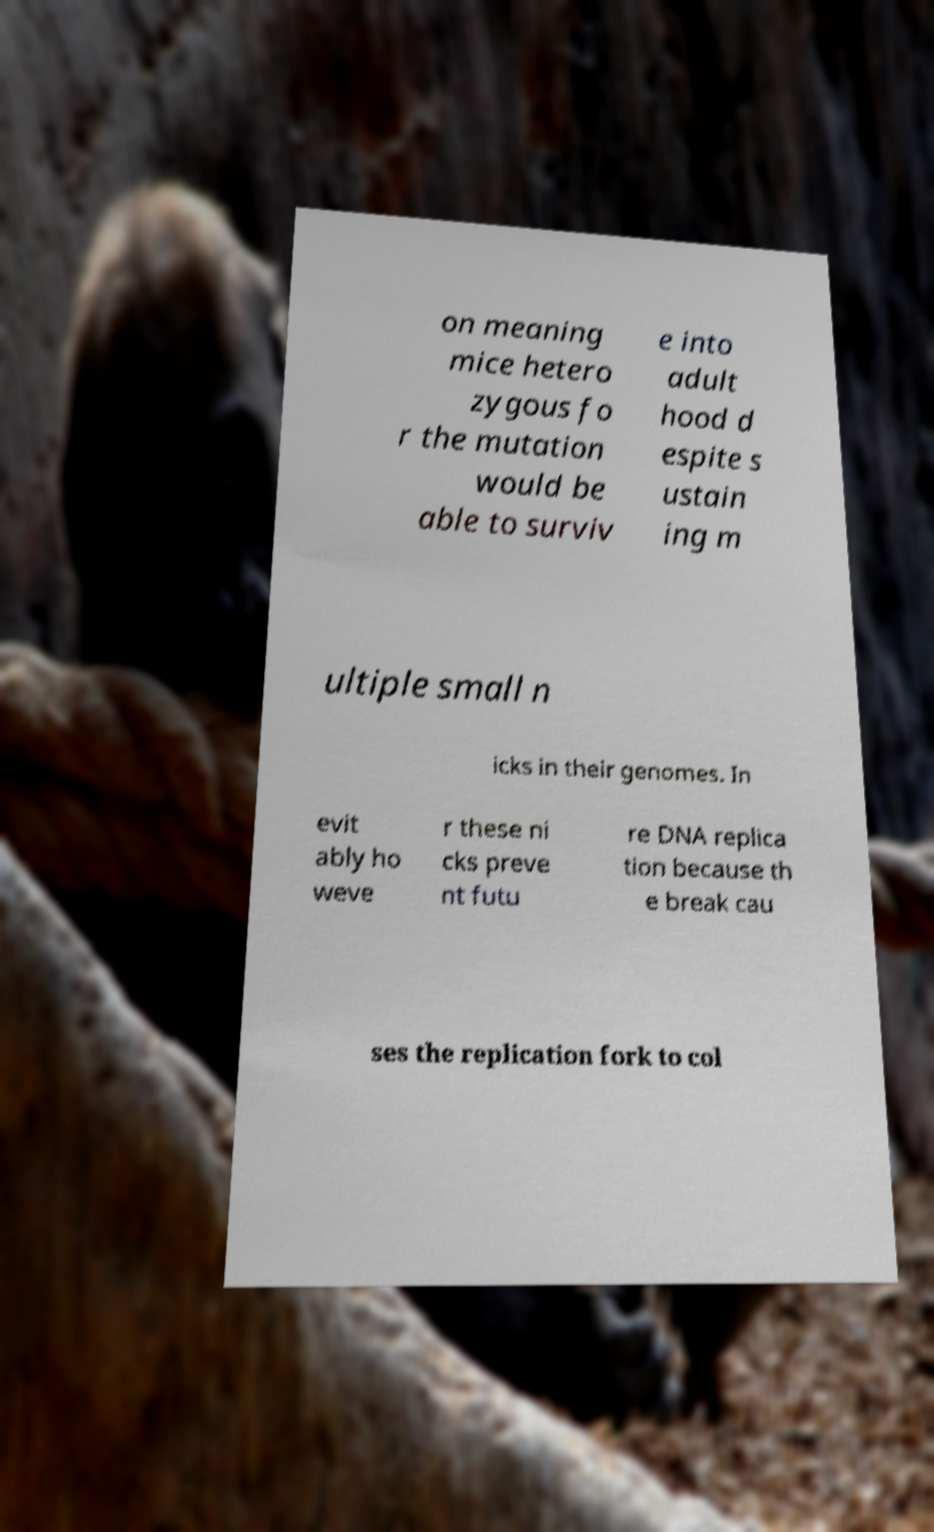For documentation purposes, I need the text within this image transcribed. Could you provide that? on meaning mice hetero zygous fo r the mutation would be able to surviv e into adult hood d espite s ustain ing m ultiple small n icks in their genomes. In evit ably ho weve r these ni cks preve nt futu re DNA replica tion because th e break cau ses the replication fork to col 